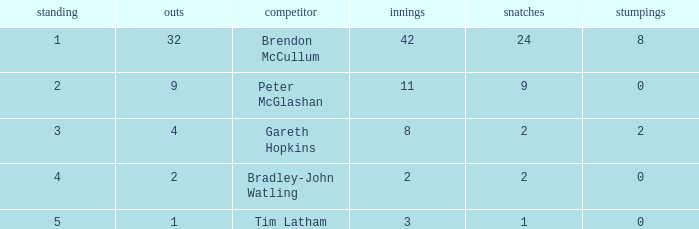How many stumpings did the player Tim Latham have? 0.0. 